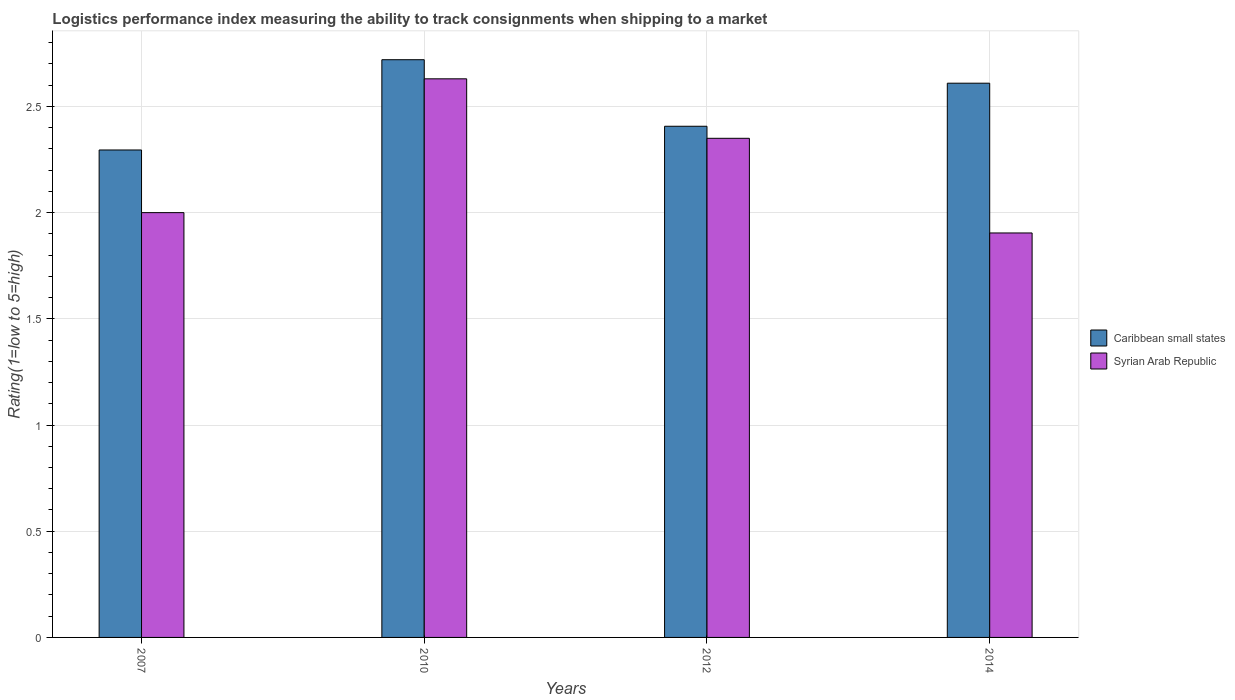Are the number of bars on each tick of the X-axis equal?
Make the answer very short. Yes. How many bars are there on the 3rd tick from the left?
Provide a short and direct response. 2. What is the Logistic performance index in Syrian Arab Republic in 2014?
Your answer should be very brief. 1.9. Across all years, what is the maximum Logistic performance index in Syrian Arab Republic?
Ensure brevity in your answer.  2.63. Across all years, what is the minimum Logistic performance index in Caribbean small states?
Offer a terse response. 2.29. In which year was the Logistic performance index in Syrian Arab Republic minimum?
Provide a succinct answer. 2014. What is the total Logistic performance index in Syrian Arab Republic in the graph?
Ensure brevity in your answer.  8.88. What is the difference between the Logistic performance index in Caribbean small states in 2007 and that in 2010?
Ensure brevity in your answer.  -0.43. What is the difference between the Logistic performance index in Syrian Arab Republic in 2010 and the Logistic performance index in Caribbean small states in 2014?
Ensure brevity in your answer.  0.02. What is the average Logistic performance index in Caribbean small states per year?
Your response must be concise. 2.51. In the year 2010, what is the difference between the Logistic performance index in Syrian Arab Republic and Logistic performance index in Caribbean small states?
Give a very brief answer. -0.09. What is the ratio of the Logistic performance index in Caribbean small states in 2007 to that in 2012?
Make the answer very short. 0.95. What is the difference between the highest and the second highest Logistic performance index in Caribbean small states?
Offer a terse response. 0.11. What is the difference between the highest and the lowest Logistic performance index in Caribbean small states?
Offer a terse response. 0.43. What does the 1st bar from the left in 2014 represents?
Offer a terse response. Caribbean small states. What does the 2nd bar from the right in 2012 represents?
Your response must be concise. Caribbean small states. Are all the bars in the graph horizontal?
Keep it short and to the point. No. How many years are there in the graph?
Make the answer very short. 4. What is the difference between two consecutive major ticks on the Y-axis?
Make the answer very short. 0.5. Are the values on the major ticks of Y-axis written in scientific E-notation?
Ensure brevity in your answer.  No. Does the graph contain grids?
Your answer should be very brief. Yes. How are the legend labels stacked?
Make the answer very short. Vertical. What is the title of the graph?
Ensure brevity in your answer.  Logistics performance index measuring the ability to track consignments when shipping to a market. Does "Argentina" appear as one of the legend labels in the graph?
Ensure brevity in your answer.  No. What is the label or title of the Y-axis?
Ensure brevity in your answer.  Rating(1=low to 5=high). What is the Rating(1=low to 5=high) in Caribbean small states in 2007?
Offer a very short reply. 2.29. What is the Rating(1=low to 5=high) of Caribbean small states in 2010?
Give a very brief answer. 2.72. What is the Rating(1=low to 5=high) in Syrian Arab Republic in 2010?
Offer a very short reply. 2.63. What is the Rating(1=low to 5=high) of Caribbean small states in 2012?
Offer a very short reply. 2.41. What is the Rating(1=low to 5=high) of Syrian Arab Republic in 2012?
Ensure brevity in your answer.  2.35. What is the Rating(1=low to 5=high) in Caribbean small states in 2014?
Your answer should be compact. 2.61. What is the Rating(1=low to 5=high) in Syrian Arab Republic in 2014?
Give a very brief answer. 1.9. Across all years, what is the maximum Rating(1=low to 5=high) in Caribbean small states?
Offer a terse response. 2.72. Across all years, what is the maximum Rating(1=low to 5=high) in Syrian Arab Republic?
Your response must be concise. 2.63. Across all years, what is the minimum Rating(1=low to 5=high) of Caribbean small states?
Offer a very short reply. 2.29. Across all years, what is the minimum Rating(1=low to 5=high) in Syrian Arab Republic?
Give a very brief answer. 1.9. What is the total Rating(1=low to 5=high) in Caribbean small states in the graph?
Ensure brevity in your answer.  10.03. What is the total Rating(1=low to 5=high) of Syrian Arab Republic in the graph?
Give a very brief answer. 8.88. What is the difference between the Rating(1=low to 5=high) of Caribbean small states in 2007 and that in 2010?
Provide a succinct answer. -0.42. What is the difference between the Rating(1=low to 5=high) of Syrian Arab Republic in 2007 and that in 2010?
Provide a succinct answer. -0.63. What is the difference between the Rating(1=low to 5=high) of Caribbean small states in 2007 and that in 2012?
Your response must be concise. -0.11. What is the difference between the Rating(1=low to 5=high) of Syrian Arab Republic in 2007 and that in 2012?
Ensure brevity in your answer.  -0.35. What is the difference between the Rating(1=low to 5=high) of Caribbean small states in 2007 and that in 2014?
Your answer should be very brief. -0.31. What is the difference between the Rating(1=low to 5=high) of Syrian Arab Republic in 2007 and that in 2014?
Provide a short and direct response. 0.1. What is the difference between the Rating(1=low to 5=high) of Caribbean small states in 2010 and that in 2012?
Give a very brief answer. 0.31. What is the difference between the Rating(1=low to 5=high) of Syrian Arab Republic in 2010 and that in 2012?
Provide a short and direct response. 0.28. What is the difference between the Rating(1=low to 5=high) in Caribbean small states in 2010 and that in 2014?
Make the answer very short. 0.11. What is the difference between the Rating(1=low to 5=high) of Syrian Arab Republic in 2010 and that in 2014?
Offer a very short reply. 0.73. What is the difference between the Rating(1=low to 5=high) in Caribbean small states in 2012 and that in 2014?
Offer a very short reply. -0.2. What is the difference between the Rating(1=low to 5=high) in Syrian Arab Republic in 2012 and that in 2014?
Provide a short and direct response. 0.45. What is the difference between the Rating(1=low to 5=high) of Caribbean small states in 2007 and the Rating(1=low to 5=high) of Syrian Arab Republic in 2010?
Offer a terse response. -0.34. What is the difference between the Rating(1=low to 5=high) of Caribbean small states in 2007 and the Rating(1=low to 5=high) of Syrian Arab Republic in 2012?
Provide a succinct answer. -0.06. What is the difference between the Rating(1=low to 5=high) of Caribbean small states in 2007 and the Rating(1=low to 5=high) of Syrian Arab Republic in 2014?
Ensure brevity in your answer.  0.39. What is the difference between the Rating(1=low to 5=high) of Caribbean small states in 2010 and the Rating(1=low to 5=high) of Syrian Arab Republic in 2012?
Provide a short and direct response. 0.37. What is the difference between the Rating(1=low to 5=high) of Caribbean small states in 2010 and the Rating(1=low to 5=high) of Syrian Arab Republic in 2014?
Keep it short and to the point. 0.82. What is the difference between the Rating(1=low to 5=high) of Caribbean small states in 2012 and the Rating(1=low to 5=high) of Syrian Arab Republic in 2014?
Keep it short and to the point. 0.5. What is the average Rating(1=low to 5=high) in Caribbean small states per year?
Your answer should be very brief. 2.51. What is the average Rating(1=low to 5=high) of Syrian Arab Republic per year?
Keep it short and to the point. 2.22. In the year 2007, what is the difference between the Rating(1=low to 5=high) of Caribbean small states and Rating(1=low to 5=high) of Syrian Arab Republic?
Ensure brevity in your answer.  0.29. In the year 2010, what is the difference between the Rating(1=low to 5=high) of Caribbean small states and Rating(1=low to 5=high) of Syrian Arab Republic?
Your answer should be very brief. 0.09. In the year 2012, what is the difference between the Rating(1=low to 5=high) of Caribbean small states and Rating(1=low to 5=high) of Syrian Arab Republic?
Provide a succinct answer. 0.06. In the year 2014, what is the difference between the Rating(1=low to 5=high) of Caribbean small states and Rating(1=low to 5=high) of Syrian Arab Republic?
Keep it short and to the point. 0.71. What is the ratio of the Rating(1=low to 5=high) in Caribbean small states in 2007 to that in 2010?
Give a very brief answer. 0.84. What is the ratio of the Rating(1=low to 5=high) of Syrian Arab Republic in 2007 to that in 2010?
Keep it short and to the point. 0.76. What is the ratio of the Rating(1=low to 5=high) of Caribbean small states in 2007 to that in 2012?
Make the answer very short. 0.95. What is the ratio of the Rating(1=low to 5=high) in Syrian Arab Republic in 2007 to that in 2012?
Your answer should be very brief. 0.85. What is the ratio of the Rating(1=low to 5=high) in Caribbean small states in 2007 to that in 2014?
Your answer should be compact. 0.88. What is the ratio of the Rating(1=low to 5=high) in Syrian Arab Republic in 2007 to that in 2014?
Provide a succinct answer. 1.05. What is the ratio of the Rating(1=low to 5=high) of Caribbean small states in 2010 to that in 2012?
Ensure brevity in your answer.  1.13. What is the ratio of the Rating(1=low to 5=high) of Syrian Arab Republic in 2010 to that in 2012?
Your answer should be very brief. 1.12. What is the ratio of the Rating(1=low to 5=high) of Caribbean small states in 2010 to that in 2014?
Offer a terse response. 1.04. What is the ratio of the Rating(1=low to 5=high) in Syrian Arab Republic in 2010 to that in 2014?
Ensure brevity in your answer.  1.38. What is the ratio of the Rating(1=low to 5=high) in Caribbean small states in 2012 to that in 2014?
Ensure brevity in your answer.  0.92. What is the ratio of the Rating(1=low to 5=high) in Syrian Arab Republic in 2012 to that in 2014?
Offer a terse response. 1.23. What is the difference between the highest and the second highest Rating(1=low to 5=high) in Caribbean small states?
Make the answer very short. 0.11. What is the difference between the highest and the second highest Rating(1=low to 5=high) in Syrian Arab Republic?
Your answer should be very brief. 0.28. What is the difference between the highest and the lowest Rating(1=low to 5=high) in Caribbean small states?
Ensure brevity in your answer.  0.42. What is the difference between the highest and the lowest Rating(1=low to 5=high) in Syrian Arab Republic?
Offer a very short reply. 0.73. 